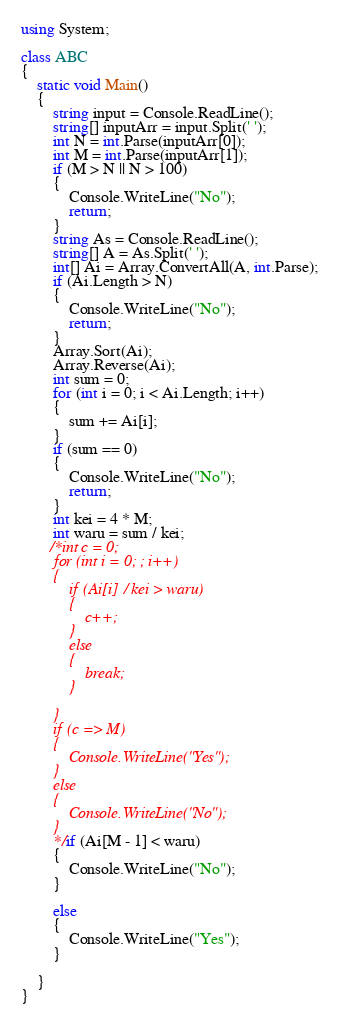<code> <loc_0><loc_0><loc_500><loc_500><_C#_>using System;

class ABC
{
    static void Main()
    {
        string input = Console.ReadLine();
        string[] inputArr = input.Split(' ');
        int N = int.Parse(inputArr[0]);
        int M = int.Parse(inputArr[1]);
        if (M > N || N > 100)
        {
            Console.WriteLine("No");
            return;
        }
        string As = Console.ReadLine();
        string[] A = As.Split(' ');
        int[] Ai = Array.ConvertAll(A, int.Parse);
        if (Ai.Length > N)
        {
            Console.WriteLine("No");
            return;
        }
        Array.Sort(Ai);
        Array.Reverse(Ai);
        int sum = 0;
        for (int i = 0; i < Ai.Length; i++)
        {
            sum += Ai[i];
        }
        if (sum == 0)
        {
            Console.WriteLine("No");
            return;
        }
        int kei = 4 * M;
        int waru = sum / kei;
       /*int c = 0;
        for (int i = 0; ; i++)
        {
            if (Ai[i] / kei > waru)
            {
                c++;
            }
            else
            {
                break;
            }

        }
        if (c => M)
        {
            Console.WriteLine("Yes");
        }
        else
        {
            Console.WriteLine("No");
        }
        */if (Ai[M - 1] < waru)
        {
            Console.WriteLine("No");
        }

        else
        {
            Console.WriteLine("Yes");
        }

    }
}</code> 